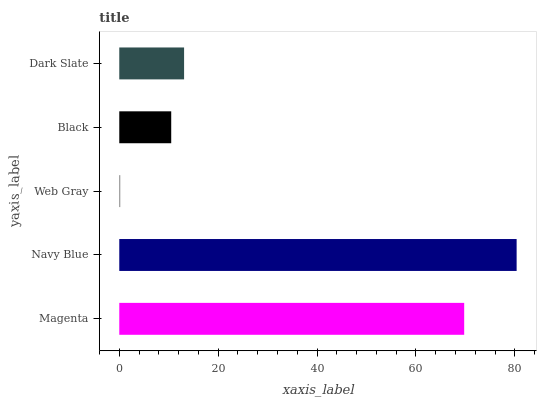Is Web Gray the minimum?
Answer yes or no. Yes. Is Navy Blue the maximum?
Answer yes or no. Yes. Is Navy Blue the minimum?
Answer yes or no. No. Is Web Gray the maximum?
Answer yes or no. No. Is Navy Blue greater than Web Gray?
Answer yes or no. Yes. Is Web Gray less than Navy Blue?
Answer yes or no. Yes. Is Web Gray greater than Navy Blue?
Answer yes or no. No. Is Navy Blue less than Web Gray?
Answer yes or no. No. Is Dark Slate the high median?
Answer yes or no. Yes. Is Dark Slate the low median?
Answer yes or no. Yes. Is Magenta the high median?
Answer yes or no. No. Is Black the low median?
Answer yes or no. No. 